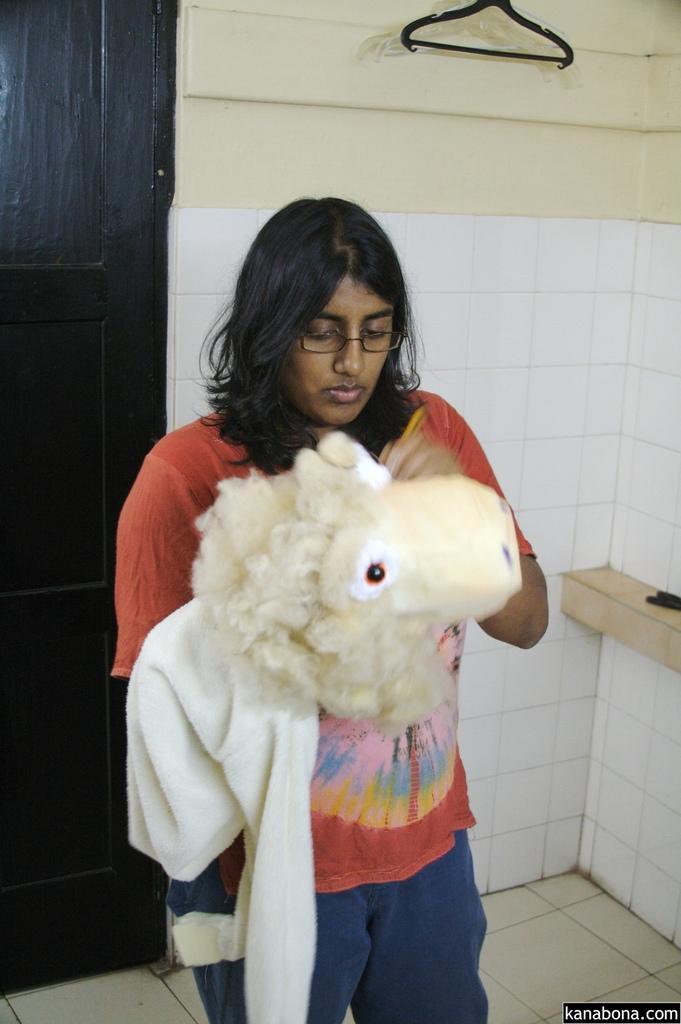In one or two sentences, can you explain what this image depicts? In this image there is a girl standing and holding a doll behind her there is a hanger at the wall. 